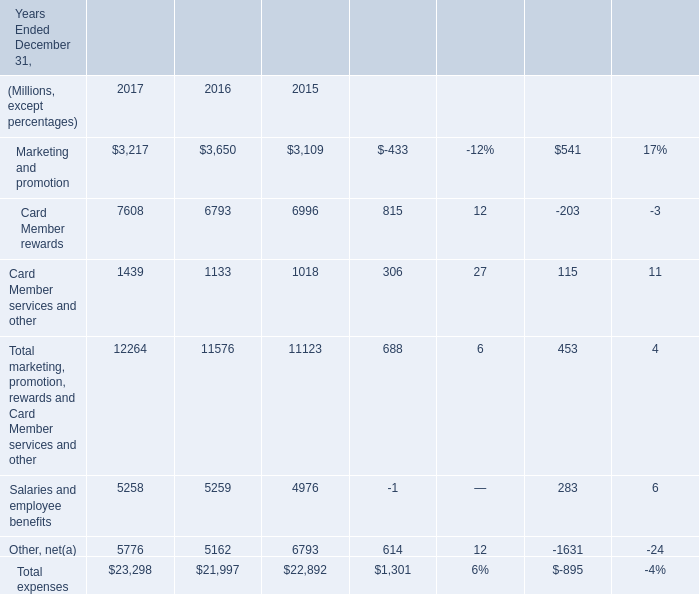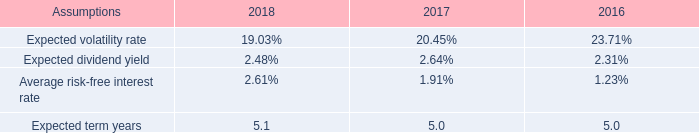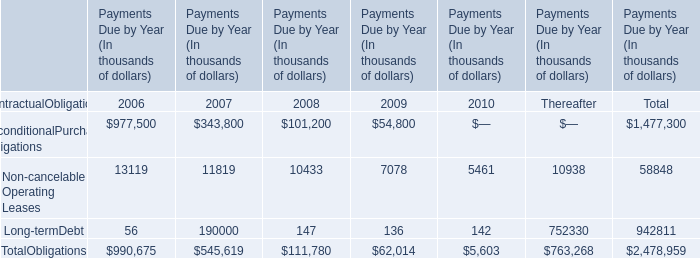What will Other, net be like in 2018 if it develops with the same increasing rate as current? (in million) 
Computations: ((1 + ((5776 - 5162) / 5162)) * 5776)
Answer: 6463.03293. 